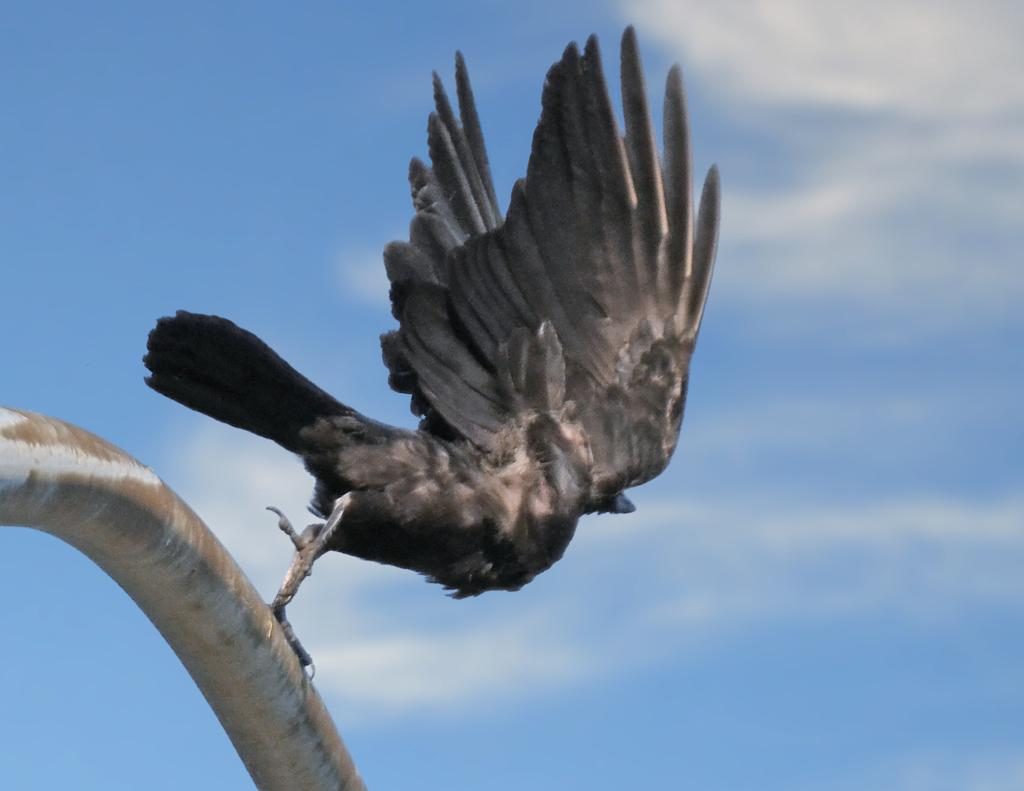What type of animal can be seen in the image? There is a bird in the image. What is the bird trying to do in the image? The bird is trying to fly. What color is the bird in the image? The bird is grey in color. What object can be seen on the left side of the image? There is an iron rod on the left side of the image. What color is the sky in the image? The sky is blue in color. Can you tell me how many tents are set up in the image? There are no tents present in the image; it features a bird trying to fly and an iron rod on the left side. What type of snake can be seen slithering in the image? There is no snake present in the image. 